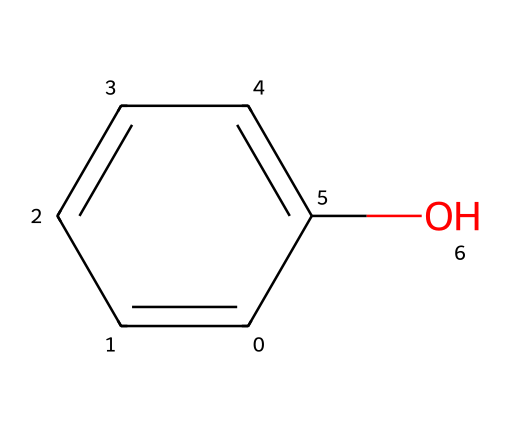What is the total number of carbon atoms in this molecule? The provided SMILES notation represents the chemical structure. By interpreting the notation, we see that there are six carbon atoms arranged in a benzene ring.
Answer: six How many oxygen atoms are present in this structure? The SMILES indicates a phenolic structure (with one hydroxyl group). Therefore, there is one oxygen atom connected to the carbon structure.
Answer: one What is the main functional group in this molecule? The structure shows a hydroxyl group (-OH) attached to the benzene ring, indicating that it is a phenol. This functional group is characteristic of phenolic compounds.
Answer: hydroxyl Which type of chemical does this represent: solid, liquid, or gas at room temperature? Considering the general properties of phenolic compounds, this structure typically represents a liquid at room temperature, as phenol is a volatile liquid.
Answer: liquid What does the presence of the hydroxyl group indicate about the solubility of this molecule? The hydroxyl group is polar, which increases the solubility of the molecule in water. This is important for understanding its behavior as a wood preservative.
Answer: soluble Is this compound likely to be used for preserving wood? Yes, due to its properties, such as anti-fungal and anti-bacterial effects provided by the phenolic structure, it is commonly used as a wood preservative.
Answer: yes 